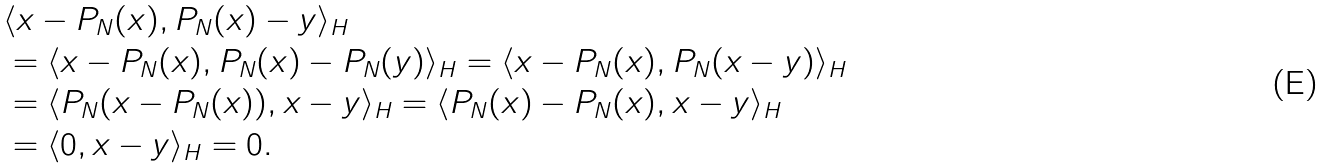<formula> <loc_0><loc_0><loc_500><loc_500>& \langle x - P _ { N } ( x ) , P _ { N } ( x ) - y \rangle _ { H } \\ & = \langle x - P _ { N } ( x ) , P _ { N } ( x ) - P _ { N } ( y ) \rangle _ { H } = \langle x - P _ { N } ( x ) , P _ { N } ( x - y ) \rangle _ { H } \\ & = \langle P _ { N } ( x - P _ { N } ( x ) ) , x - y \rangle _ { H } = \langle P _ { N } ( x ) - P _ { N } ( x ) , x - y \rangle _ { H } \\ & = \langle 0 , x - y \rangle _ { H } = 0 .</formula> 